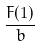Convert formula to latex. <formula><loc_0><loc_0><loc_500><loc_500>\frac { F ( 1 ) } { b }</formula> 